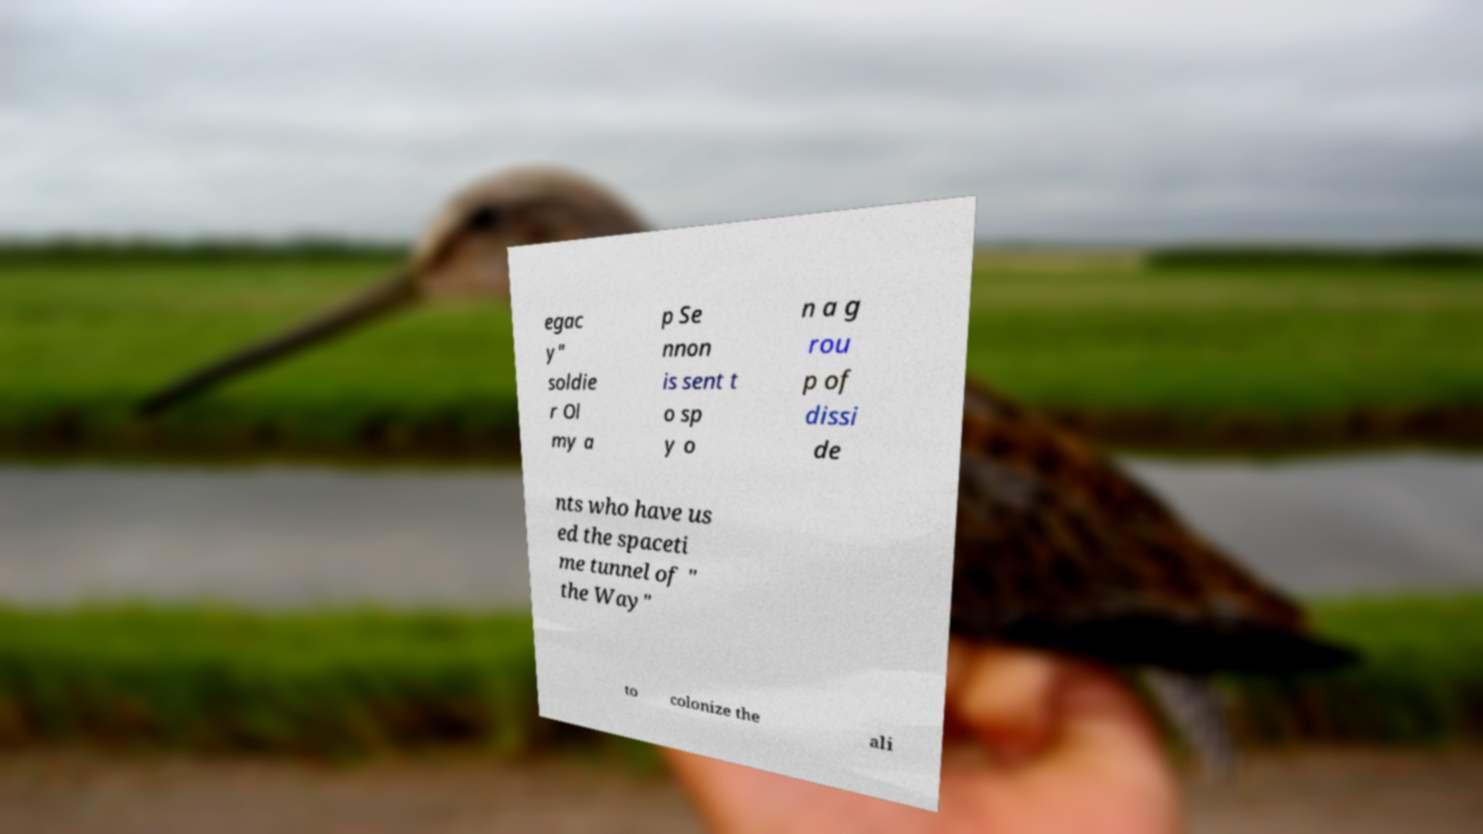For documentation purposes, I need the text within this image transcribed. Could you provide that? egac y" soldie r Ol my a p Se nnon is sent t o sp y o n a g rou p of dissi de nts who have us ed the spaceti me tunnel of " the Way" to colonize the ali 